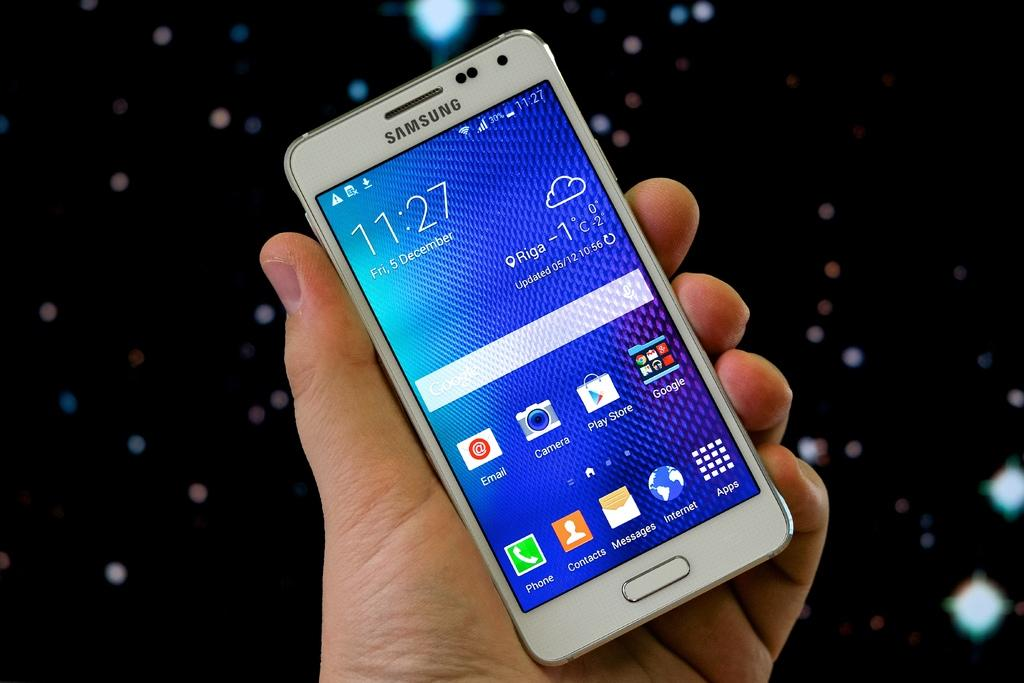Provide a one-sentence caption for the provided image. Hand holding a cellphone that shows 11:27 on the screen. 